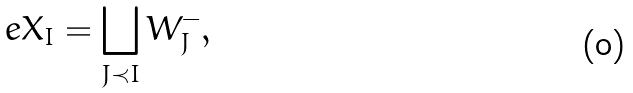<formula> <loc_0><loc_0><loc_500><loc_500>\ e X _ { I } = \bigsqcup _ { J \prec I } W _ { J } ^ { - } ,</formula> 